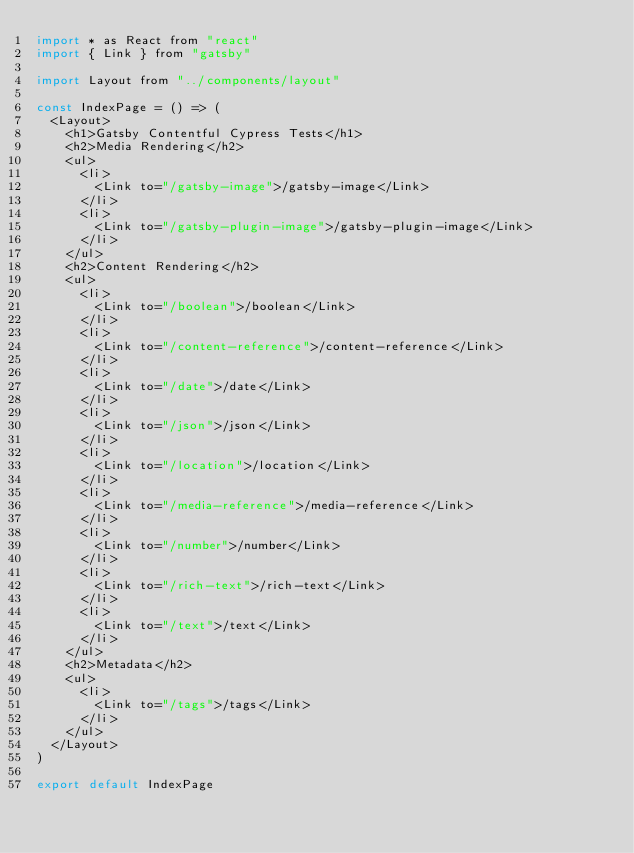<code> <loc_0><loc_0><loc_500><loc_500><_JavaScript_>import * as React from "react"
import { Link } from "gatsby"

import Layout from "../components/layout"

const IndexPage = () => (
  <Layout>
    <h1>Gatsby Contentful Cypress Tests</h1>
    <h2>Media Rendering</h2>
    <ul>
      <li>
        <Link to="/gatsby-image">/gatsby-image</Link>
      </li>
      <li>
        <Link to="/gatsby-plugin-image">/gatsby-plugin-image</Link>
      </li>
    </ul>
    <h2>Content Rendering</h2>
    <ul>
      <li>
        <Link to="/boolean">/boolean</Link>
      </li>
      <li>
        <Link to="/content-reference">/content-reference</Link>
      </li>
      <li>
        <Link to="/date">/date</Link>
      </li>
      <li>
        <Link to="/json">/json</Link>
      </li>
      <li>
        <Link to="/location">/location</Link>
      </li>
      <li>
        <Link to="/media-reference">/media-reference</Link>
      </li>
      <li>
        <Link to="/number">/number</Link>
      </li>
      <li>
        <Link to="/rich-text">/rich-text</Link>
      </li>
      <li>
        <Link to="/text">/text</Link>
      </li>
    </ul>
    <h2>Metadata</h2>
    <ul>
      <li>
        <Link to="/tags">/tags</Link>
      </li>
    </ul>
  </Layout>
)

export default IndexPage
</code> 